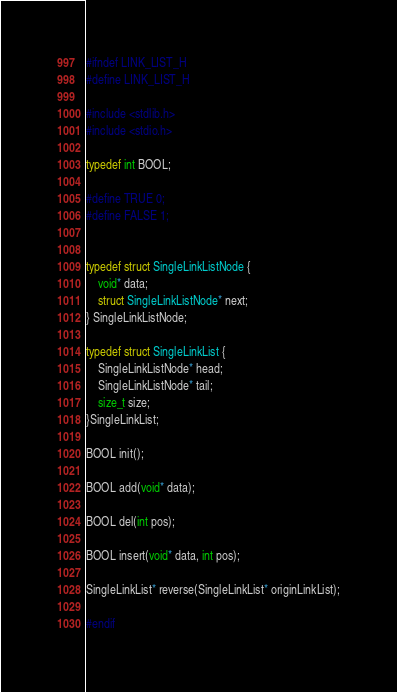<code> <loc_0><loc_0><loc_500><loc_500><_C_>#ifndef LINK_LIST_H
#define LINK_LIST_H

#include <stdlib.h>
#include <stdio.h>

typedef int BOOL;

#define TRUE 0;
#define FALSE 1;


typedef struct SingleLinkListNode {
    void* data;
    struct SingleLinkListNode* next; 
} SingleLinkListNode;

typedef struct SingleLinkList {
    SingleLinkListNode* head;
    SingleLinkListNode* tail;
    size_t size;
}SingleLinkList;

BOOL init();

BOOL add(void* data);

BOOL del(int pos);

BOOL insert(void* data, int pos);

SingleLinkList* reverse(SingleLinkList* originLinkList);

#endif</code> 